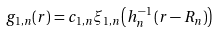Convert formula to latex. <formula><loc_0><loc_0><loc_500><loc_500>g _ { 1 , n } ( r ) = c _ { 1 , n } \xi _ { 1 , n } \left ( h _ { n } ^ { - 1 } \left ( r - R _ { n } \right ) \right )</formula> 